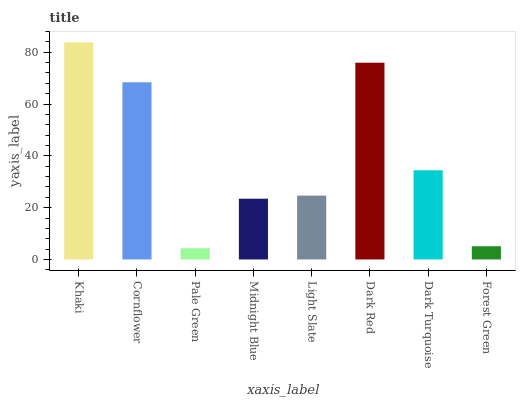Is Pale Green the minimum?
Answer yes or no. Yes. Is Khaki the maximum?
Answer yes or no. Yes. Is Cornflower the minimum?
Answer yes or no. No. Is Cornflower the maximum?
Answer yes or no. No. Is Khaki greater than Cornflower?
Answer yes or no. Yes. Is Cornflower less than Khaki?
Answer yes or no. Yes. Is Cornflower greater than Khaki?
Answer yes or no. No. Is Khaki less than Cornflower?
Answer yes or no. No. Is Dark Turquoise the high median?
Answer yes or no. Yes. Is Light Slate the low median?
Answer yes or no. Yes. Is Midnight Blue the high median?
Answer yes or no. No. Is Cornflower the low median?
Answer yes or no. No. 